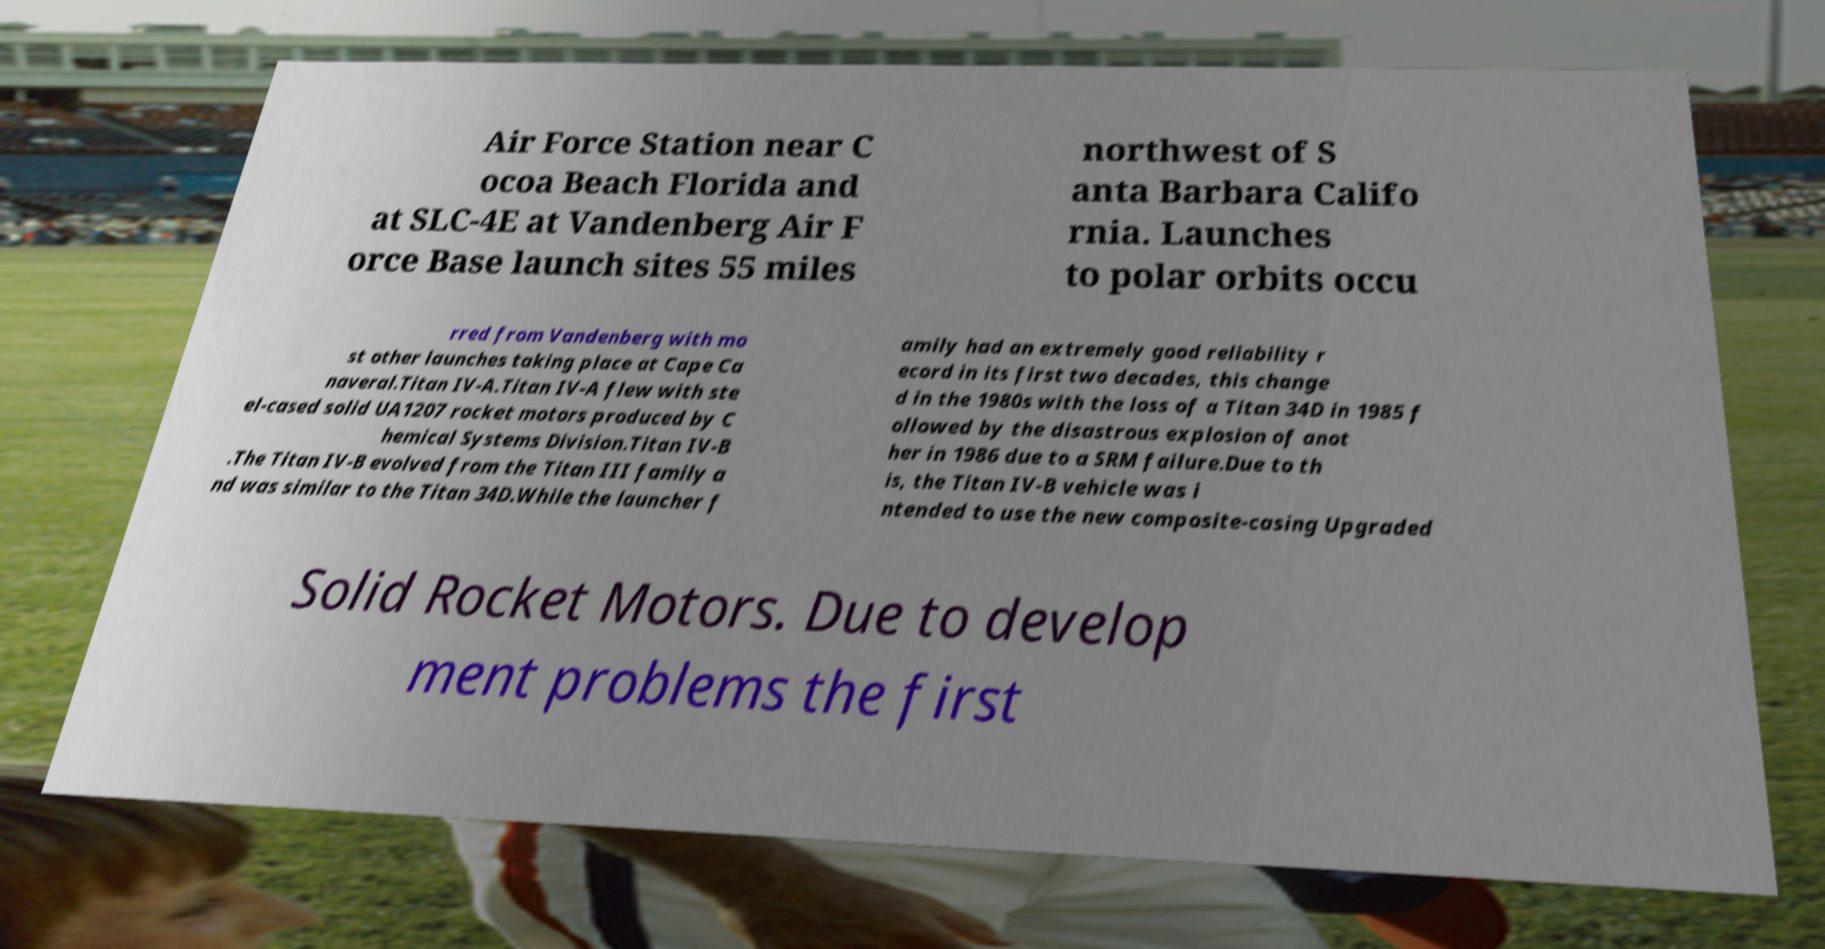Can you accurately transcribe the text from the provided image for me? Air Force Station near C ocoa Beach Florida and at SLC-4E at Vandenberg Air F orce Base launch sites 55 miles northwest of S anta Barbara Califo rnia. Launches to polar orbits occu rred from Vandenberg with mo st other launches taking place at Cape Ca naveral.Titan IV-A.Titan IV-A flew with ste el-cased solid UA1207 rocket motors produced by C hemical Systems Division.Titan IV-B .The Titan IV-B evolved from the Titan III family a nd was similar to the Titan 34D.While the launcher f amily had an extremely good reliability r ecord in its first two decades, this change d in the 1980s with the loss of a Titan 34D in 1985 f ollowed by the disastrous explosion of anot her in 1986 due to a SRM failure.Due to th is, the Titan IV-B vehicle was i ntended to use the new composite-casing Upgraded Solid Rocket Motors. Due to develop ment problems the first 